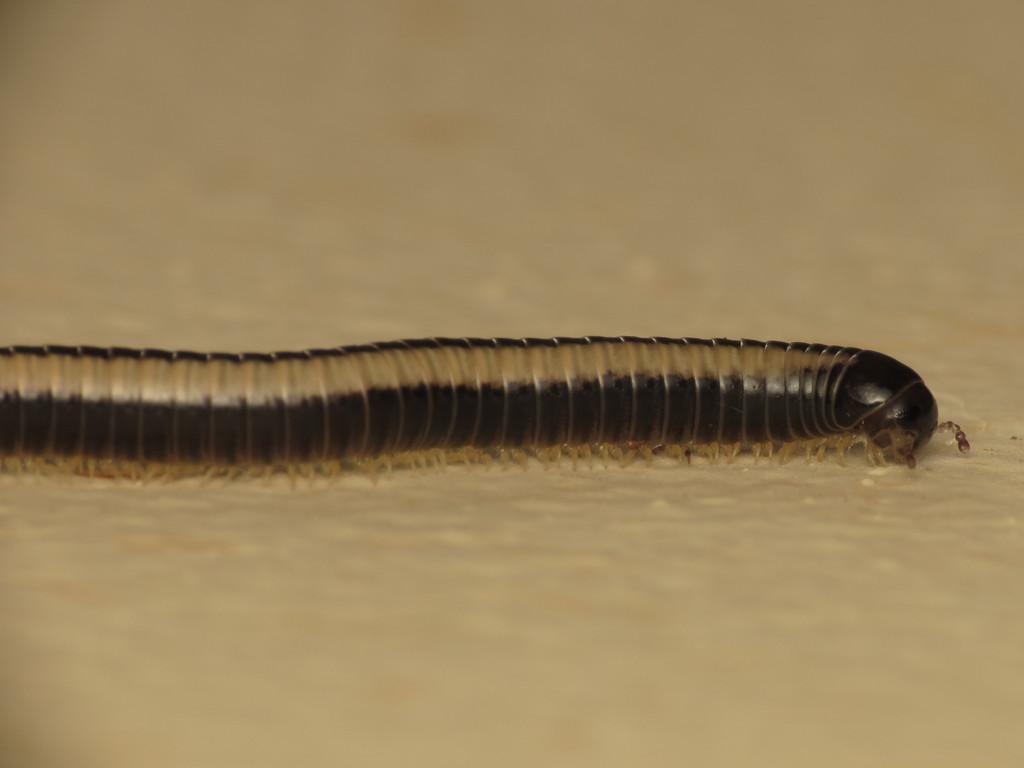In one or two sentences, can you explain what this image depicts? Here in this picture we can see an insect present on the ground over there. 